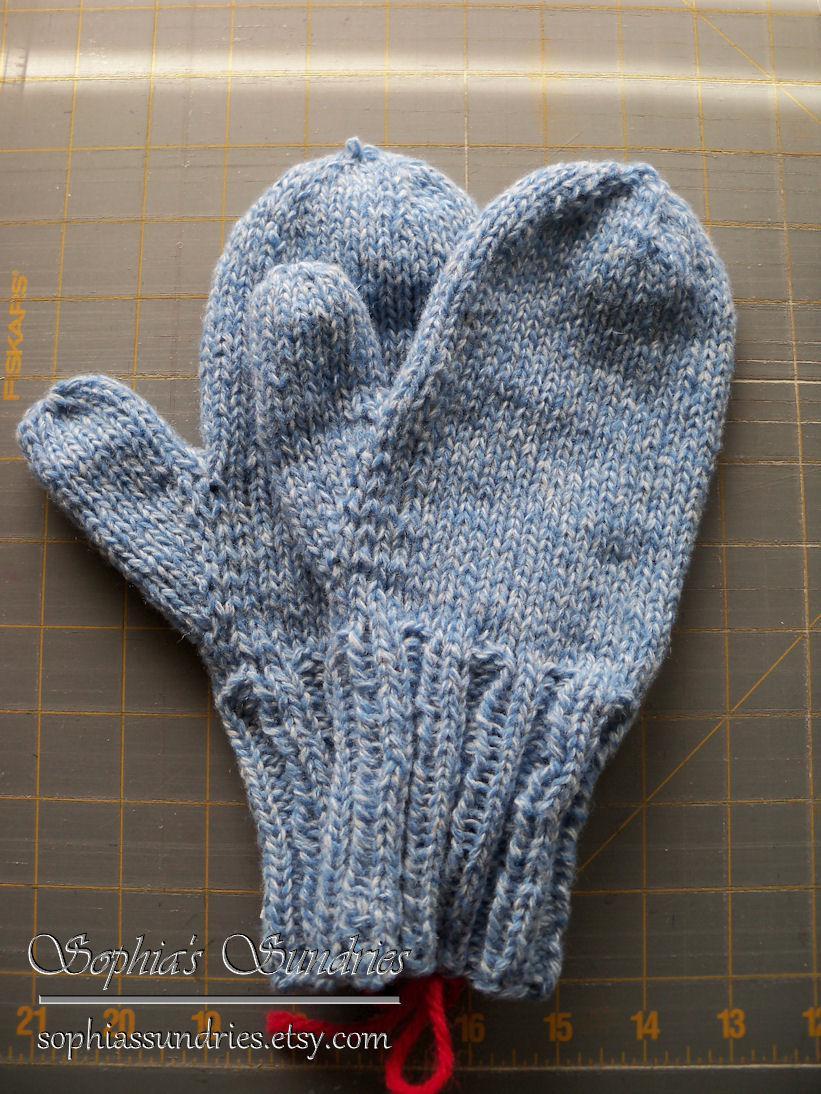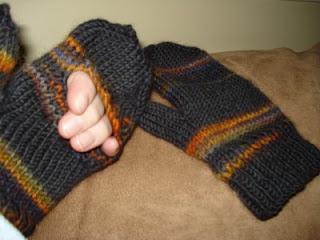The first image is the image on the left, the second image is the image on the right. For the images displayed, is the sentence "There are no less than three mittens" factually correct? Answer yes or no. Yes. 